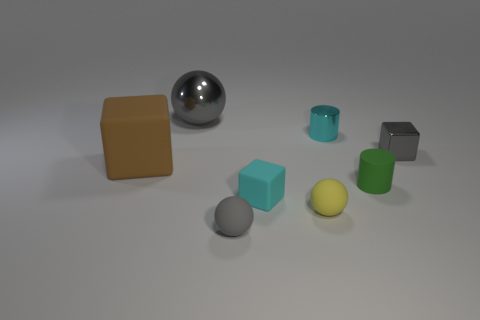The small ball that is to the left of the cyan object that is on the left side of the small yellow rubber thing is what color?
Offer a very short reply. Gray. Are there more cyan objects in front of the large rubber thing than rubber cylinders that are to the left of the cyan shiny cylinder?
Provide a succinct answer. Yes. Is the material of the gray thing right of the small gray rubber ball the same as the ball that is behind the tiny gray cube?
Provide a short and direct response. Yes. Are there any tiny rubber cylinders in front of the tiny shiny cylinder?
Your answer should be compact. Yes. How many yellow things are tiny balls or tiny metallic cylinders?
Your response must be concise. 1. Do the tiny green cylinder and the tiny gray thing that is in front of the tiny green cylinder have the same material?
Keep it short and to the point. Yes. What size is the cyan rubber object that is the same shape as the brown thing?
Offer a terse response. Small. What material is the green cylinder?
Your answer should be very brief. Rubber. There is a tiny block behind the cyan object on the left side of the tiny cyan object that is behind the big rubber object; what is it made of?
Your response must be concise. Metal. Does the matte thing that is in front of the small yellow thing have the same size as the cyan matte cube that is in front of the small metallic cylinder?
Keep it short and to the point. Yes. 